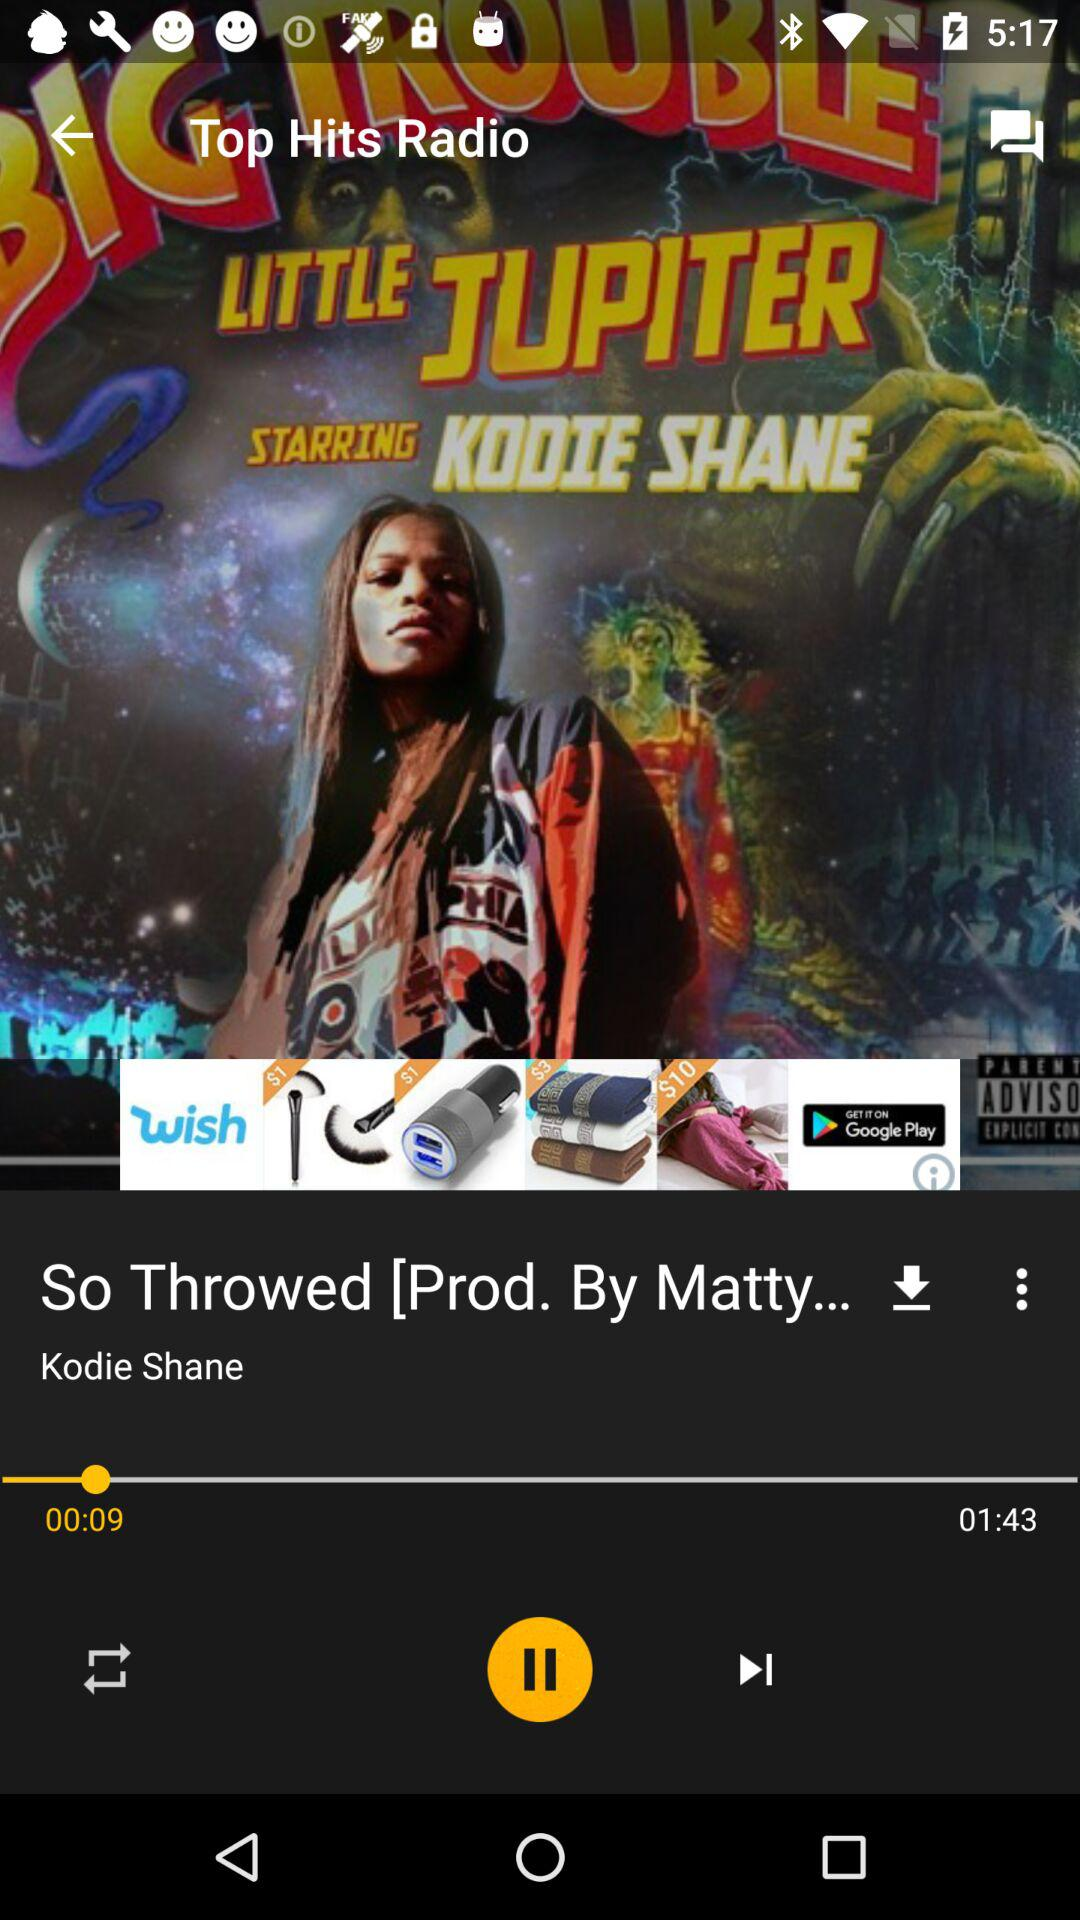Which radio stations are available?
When the provided information is insufficient, respond with <no answer>. <no answer> 